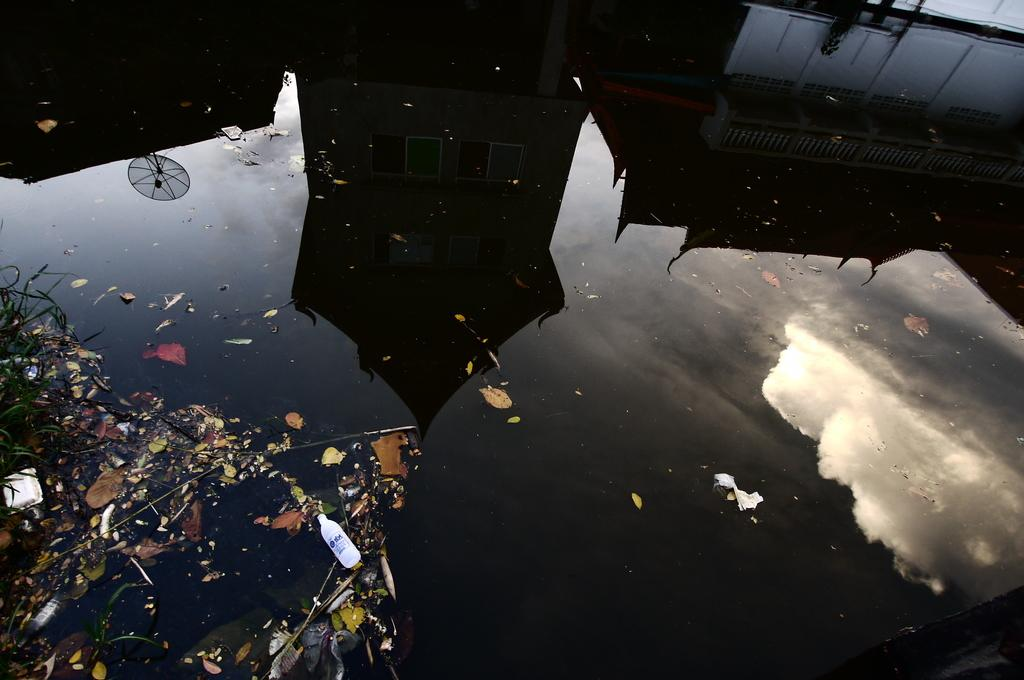What is reflected on the water in the image? There is a building reflection on the water in the image. Can you see a farmer holding a pen and a gun in the image? There is no farmer, pen, or gun present in the image. The image only features a building reflection on the water. 